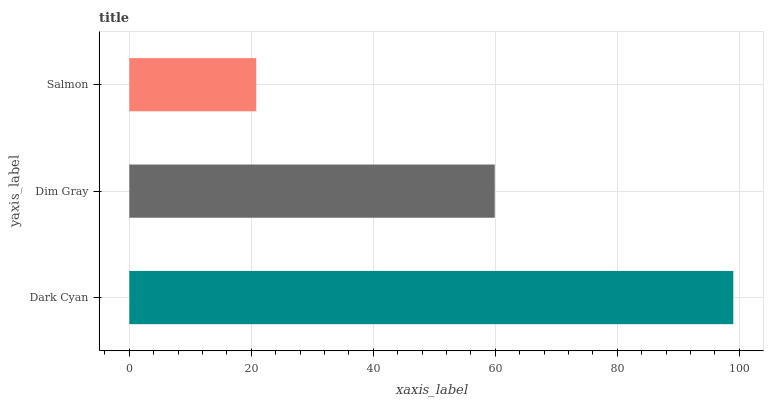Is Salmon the minimum?
Answer yes or no. Yes. Is Dark Cyan the maximum?
Answer yes or no. Yes. Is Dim Gray the minimum?
Answer yes or no. No. Is Dim Gray the maximum?
Answer yes or no. No. Is Dark Cyan greater than Dim Gray?
Answer yes or no. Yes. Is Dim Gray less than Dark Cyan?
Answer yes or no. Yes. Is Dim Gray greater than Dark Cyan?
Answer yes or no. No. Is Dark Cyan less than Dim Gray?
Answer yes or no. No. Is Dim Gray the high median?
Answer yes or no. Yes. Is Dim Gray the low median?
Answer yes or no. Yes. Is Salmon the high median?
Answer yes or no. No. Is Salmon the low median?
Answer yes or no. No. 